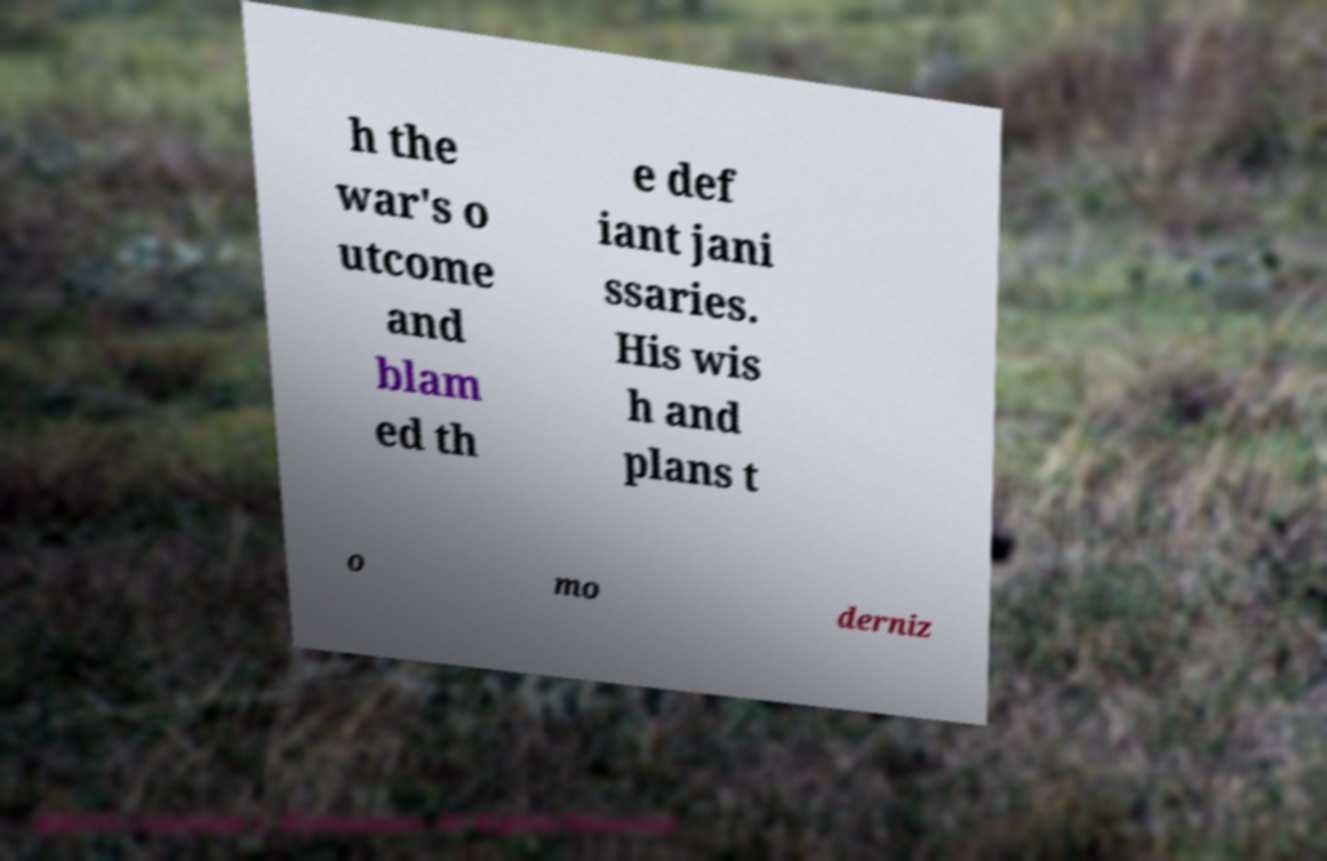Could you extract and type out the text from this image? h the war's o utcome and blam ed th e def iant jani ssaries. His wis h and plans t o mo derniz 